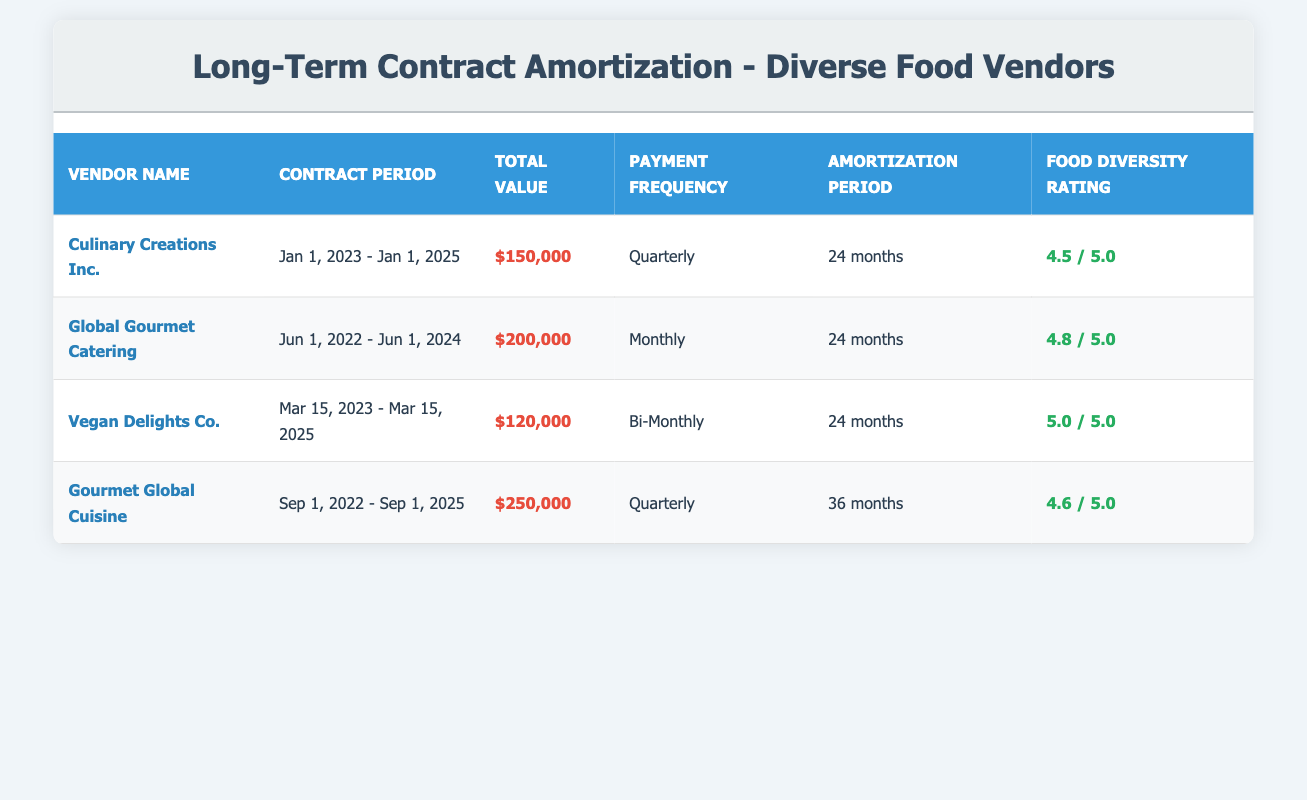What is the total value of the contract with Culinary Creations Inc.? The table shows that the total contract value with Culinary Creations Inc. is listed under the "Total Value" column. According to the data, this value is $150,000.
Answer: $150,000 How many contracts have a payment frequency of "Quarterly"? By examining the "Payment Frequency" column in the table, we can count the contracts listed. Culinary Creations Inc. and Gourmet Global Cuisine both have a payment frequency listed as "Quarterly," making a total of 2 contracts.
Answer: 2 What is the average food diversity rating of all the vendors? To find the average, we add the diversity ratings: 4.5 + 4.8 + 5.0 + 4.6 = 19.0. Then we divide by the number of vendors (4): 19.0 / 4 = 4.75.
Answer: 4.75 Is the total value of Vegan Delights Co. greater than $100,000? The total value for Vegan Delights Co. is $120,000 according to the “Total Value” column. Since $120,000 is greater than $100,000, the answer is yes.
Answer: Yes What is the contract duration for Global Gourmet Catering? The contract period for Global Gourmet Catering is provided in the "Contract Period" column, which states it runs from June 1, 2022, to June 1, 2024. This gives a duration of 24 months.
Answer: 24 months Which vendor has the highest food diversity rating? By comparing the ratings in the "Food Diversity Rating" column, we see that Vegan Delights Co. has a rating of 5.0, which is higher than the other vendors.
Answer: Vegan Delights Co What is the sum of the total contract values for the vendors with a bi-monthly payment frequency? The table lists Vegan Delights Co. with a total contract value of $120,000. As it is the only vendor with a bi-monthly payment frequency, the sum is $120,000.
Answer: $120,000 How many contracts end after January 2025? By looking at the "Contract Period" column, we identify that the contracts for Global Gourmet Catering and Gourmet Global Cuisine end after January 2025. Global Gourmet Catering ends on June 1, 2024, while Gourmet Global Cuisine ends on September 1, 2025. Thus, there is 1 contract that ends after January 2025.
Answer: 1 Do any of the contracts have a payment frequency of "Bi-Monthly"? Examining the "Payment Frequency" column, we find that Vegan Delights Co. has a payment frequency labeled as "Bi-Monthly." Consequently, the answer is yes.
Answer: Yes 